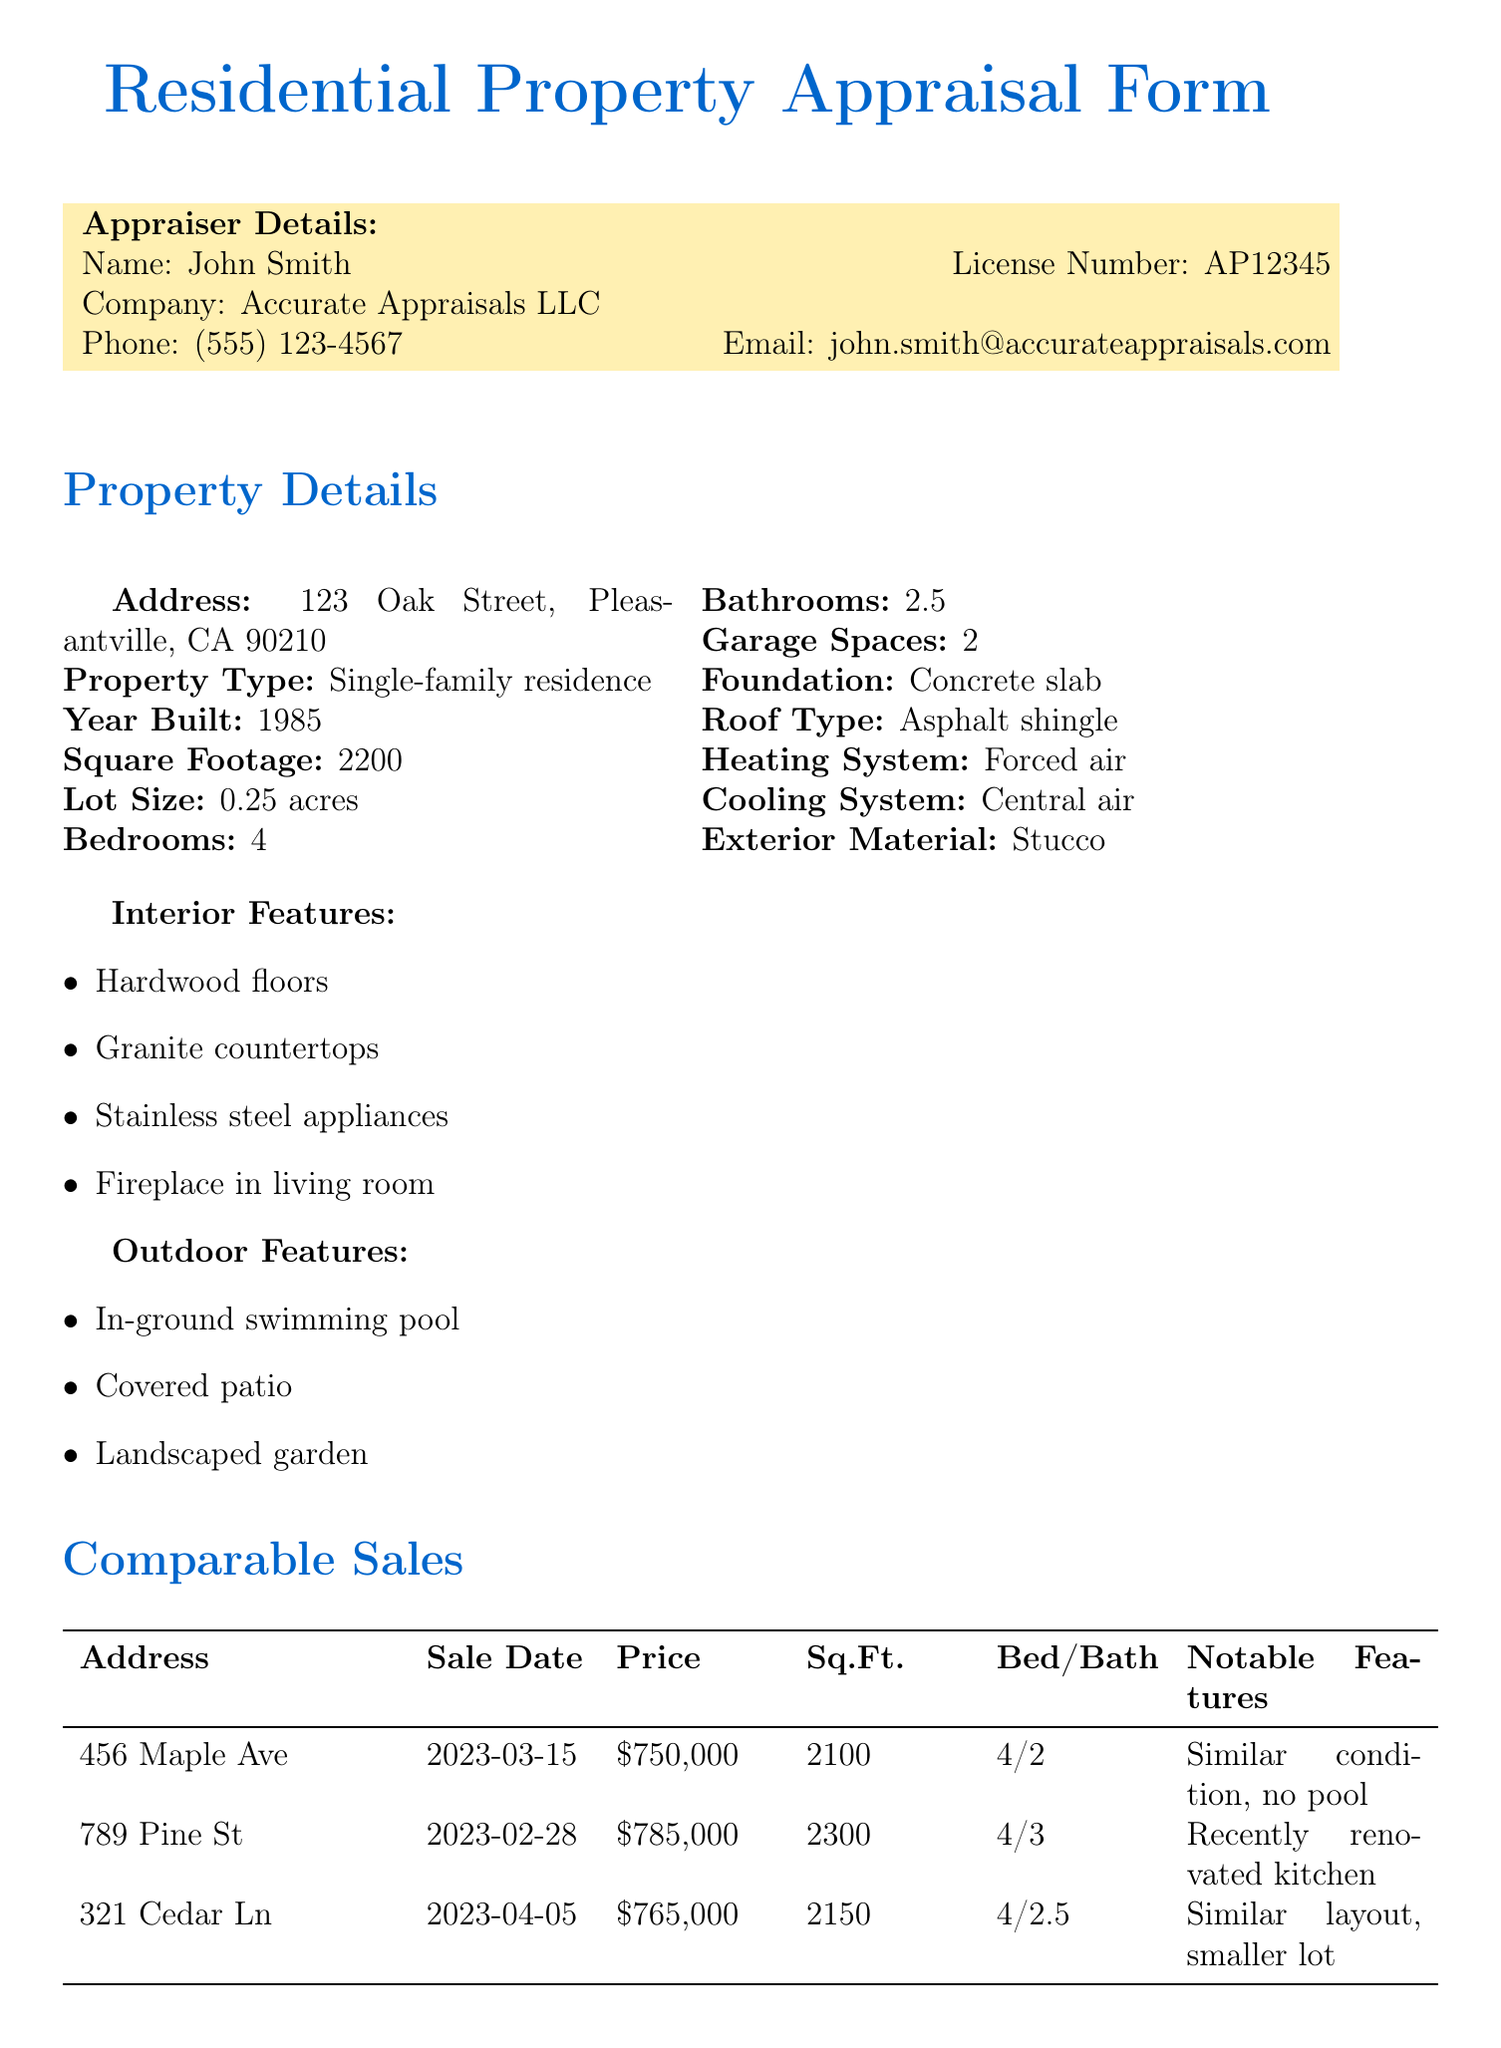What is the appraiser's name? The appraiser's name is listed in the document under the appraiser details section.
Answer: John Smith What is the sale price of the property at 789 Pine St? The sale price is found in the comparable sales table, specifically for the property at 789 Pine St.
Answer: $785,000 What is the square footage of the subject property? The square footage is provided in the property details section of the document.
Answer: 2200 What year was the subject property built? The year built is specified in the property details of the document.
Answer: 1985 What notable feature is mentioned for 456 Maple Ave? The notable feature can be found in the comparable sales section for the property at 456 Maple Ave.
Answer: Similar condition, no pool What is the appraised value of the subject property? The appraised value is stated in the final valuation section of the document.
Answer: $775,000 How many bathrooms does the subject property have? The number of bathrooms is outlined in the property details section of the document.
Answer: 2.5 What market condition is mentioned? The market conditions section contains information about the current market trends.
Answer: Stable market with slight appreciation What recent improvements were made to the property? Recent improvements are listed in the additional notes section of the document.
Answer: New roof (2021) and updated HVAC system (2022) 